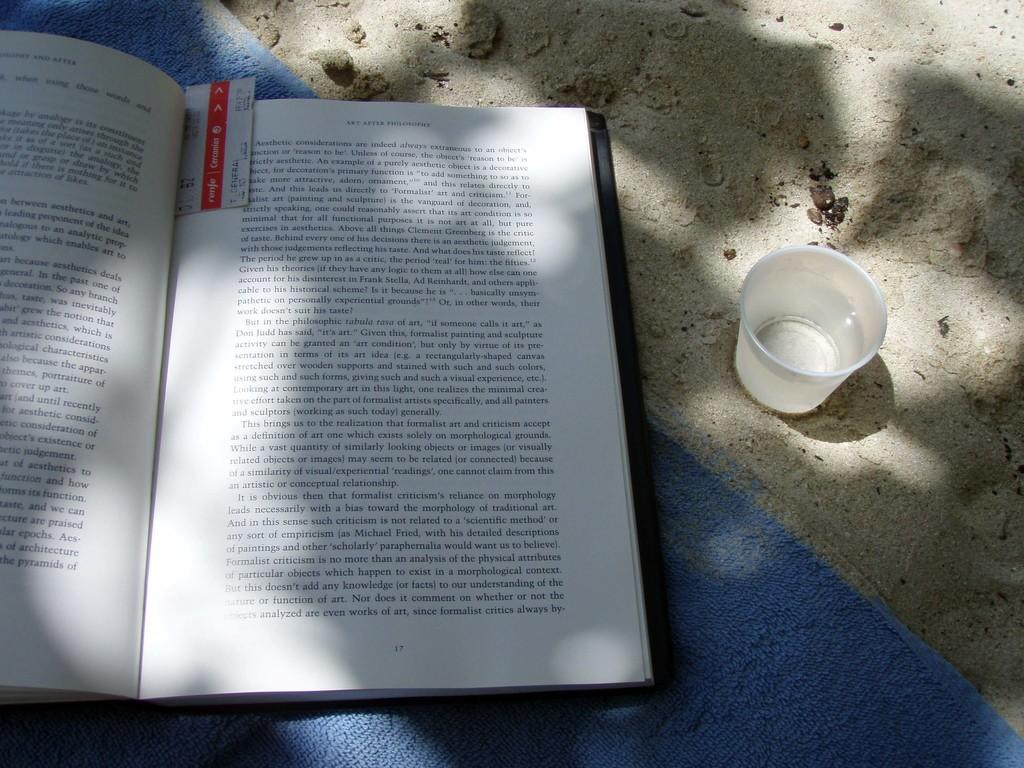<image>
Provide a brief description of the given image. A page from a book about Art is shown as the book is on a towel on the sand. 